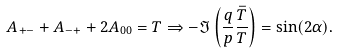<formula> <loc_0><loc_0><loc_500><loc_500>A _ { + - } + A _ { - + } + 2 A _ { 0 0 } = T \Rightarrow - \Im \left ( \frac { q } { p } \frac { \bar { T } } { T } \right ) = \sin ( 2 \alpha ) .</formula> 